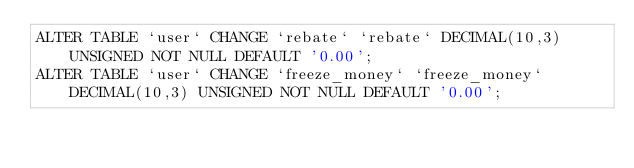Convert code to text. <code><loc_0><loc_0><loc_500><loc_500><_SQL_>ALTER TABLE `user` CHANGE `rebate` `rebate` DECIMAL(10,3) UNSIGNED NOT NULL DEFAULT '0.00';
ALTER TABLE `user` CHANGE `freeze_money` `freeze_money` DECIMAL(10,3) UNSIGNED NOT NULL DEFAULT '0.00';
</code> 